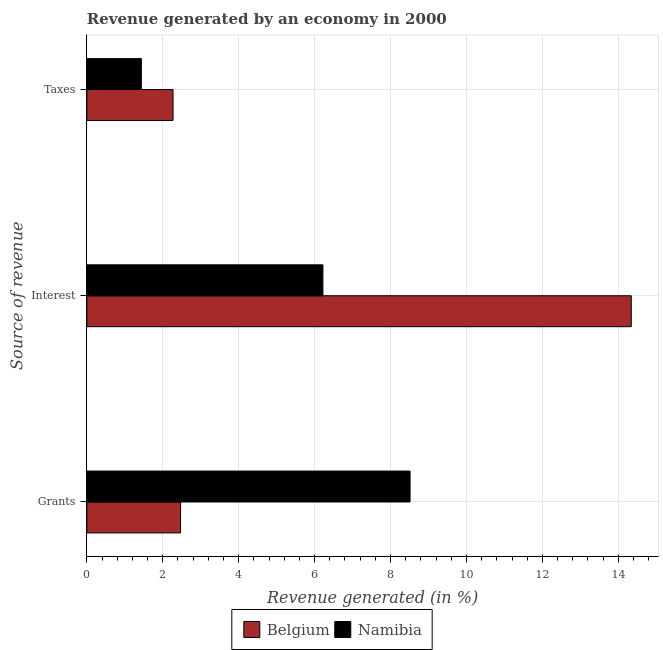Are the number of bars per tick equal to the number of legend labels?
Ensure brevity in your answer.  Yes. Are the number of bars on each tick of the Y-axis equal?
Ensure brevity in your answer.  Yes. How many bars are there on the 1st tick from the top?
Provide a short and direct response. 2. What is the label of the 2nd group of bars from the top?
Keep it short and to the point. Interest. What is the percentage of revenue generated by taxes in Namibia?
Offer a very short reply. 1.44. Across all countries, what is the maximum percentage of revenue generated by interest?
Your answer should be very brief. 14.34. Across all countries, what is the minimum percentage of revenue generated by interest?
Keep it short and to the point. 6.22. What is the total percentage of revenue generated by taxes in the graph?
Provide a short and direct response. 3.71. What is the difference between the percentage of revenue generated by interest in Belgium and that in Namibia?
Provide a succinct answer. 8.12. What is the difference between the percentage of revenue generated by grants in Namibia and the percentage of revenue generated by taxes in Belgium?
Make the answer very short. 6.24. What is the average percentage of revenue generated by taxes per country?
Your answer should be very brief. 1.85. What is the difference between the percentage of revenue generated by grants and percentage of revenue generated by interest in Belgium?
Your response must be concise. -11.87. What is the ratio of the percentage of revenue generated by taxes in Belgium to that in Namibia?
Your response must be concise. 1.58. Is the difference between the percentage of revenue generated by grants in Belgium and Namibia greater than the difference between the percentage of revenue generated by interest in Belgium and Namibia?
Offer a terse response. No. What is the difference between the highest and the second highest percentage of revenue generated by grants?
Your answer should be compact. 6.05. What is the difference between the highest and the lowest percentage of revenue generated by taxes?
Offer a terse response. 0.83. In how many countries, is the percentage of revenue generated by taxes greater than the average percentage of revenue generated by taxes taken over all countries?
Provide a succinct answer. 1. Is the sum of the percentage of revenue generated by grants in Namibia and Belgium greater than the maximum percentage of revenue generated by interest across all countries?
Offer a terse response. No. What does the 2nd bar from the bottom in Grants represents?
Keep it short and to the point. Namibia. Are all the bars in the graph horizontal?
Keep it short and to the point. Yes. How many countries are there in the graph?
Your answer should be very brief. 2. Are the values on the major ticks of X-axis written in scientific E-notation?
Ensure brevity in your answer.  No. How many legend labels are there?
Your answer should be very brief. 2. How are the legend labels stacked?
Offer a very short reply. Horizontal. What is the title of the graph?
Your answer should be compact. Revenue generated by an economy in 2000. What is the label or title of the X-axis?
Your response must be concise. Revenue generated (in %). What is the label or title of the Y-axis?
Provide a succinct answer. Source of revenue. What is the Revenue generated (in %) in Belgium in Grants?
Your answer should be very brief. 2.47. What is the Revenue generated (in %) of Namibia in Grants?
Offer a very short reply. 8.51. What is the Revenue generated (in %) of Belgium in Interest?
Your response must be concise. 14.34. What is the Revenue generated (in %) of Namibia in Interest?
Give a very brief answer. 6.22. What is the Revenue generated (in %) of Belgium in Taxes?
Offer a terse response. 2.27. What is the Revenue generated (in %) in Namibia in Taxes?
Provide a succinct answer. 1.44. Across all Source of revenue, what is the maximum Revenue generated (in %) in Belgium?
Offer a very short reply. 14.34. Across all Source of revenue, what is the maximum Revenue generated (in %) of Namibia?
Give a very brief answer. 8.51. Across all Source of revenue, what is the minimum Revenue generated (in %) in Belgium?
Your response must be concise. 2.27. Across all Source of revenue, what is the minimum Revenue generated (in %) of Namibia?
Offer a terse response. 1.44. What is the total Revenue generated (in %) in Belgium in the graph?
Your answer should be very brief. 19.08. What is the total Revenue generated (in %) of Namibia in the graph?
Your answer should be compact. 16.17. What is the difference between the Revenue generated (in %) in Belgium in Grants and that in Interest?
Your answer should be compact. -11.87. What is the difference between the Revenue generated (in %) of Namibia in Grants and that in Interest?
Give a very brief answer. 2.3. What is the difference between the Revenue generated (in %) in Belgium in Grants and that in Taxes?
Ensure brevity in your answer.  0.2. What is the difference between the Revenue generated (in %) in Namibia in Grants and that in Taxes?
Keep it short and to the point. 7.08. What is the difference between the Revenue generated (in %) in Belgium in Interest and that in Taxes?
Provide a short and direct response. 12.07. What is the difference between the Revenue generated (in %) in Namibia in Interest and that in Taxes?
Keep it short and to the point. 4.78. What is the difference between the Revenue generated (in %) in Belgium in Grants and the Revenue generated (in %) in Namibia in Interest?
Make the answer very short. -3.75. What is the difference between the Revenue generated (in %) in Belgium in Grants and the Revenue generated (in %) in Namibia in Taxes?
Provide a succinct answer. 1.03. What is the difference between the Revenue generated (in %) of Belgium in Interest and the Revenue generated (in %) of Namibia in Taxes?
Offer a very short reply. 12.91. What is the average Revenue generated (in %) in Belgium per Source of revenue?
Keep it short and to the point. 6.36. What is the average Revenue generated (in %) of Namibia per Source of revenue?
Your response must be concise. 5.39. What is the difference between the Revenue generated (in %) of Belgium and Revenue generated (in %) of Namibia in Grants?
Your answer should be very brief. -6.05. What is the difference between the Revenue generated (in %) of Belgium and Revenue generated (in %) of Namibia in Interest?
Offer a terse response. 8.12. What is the difference between the Revenue generated (in %) of Belgium and Revenue generated (in %) of Namibia in Taxes?
Your response must be concise. 0.83. What is the ratio of the Revenue generated (in %) of Belgium in Grants to that in Interest?
Ensure brevity in your answer.  0.17. What is the ratio of the Revenue generated (in %) of Namibia in Grants to that in Interest?
Offer a very short reply. 1.37. What is the ratio of the Revenue generated (in %) in Belgium in Grants to that in Taxes?
Give a very brief answer. 1.09. What is the ratio of the Revenue generated (in %) in Namibia in Grants to that in Taxes?
Provide a short and direct response. 5.93. What is the ratio of the Revenue generated (in %) of Belgium in Interest to that in Taxes?
Provide a succinct answer. 6.32. What is the ratio of the Revenue generated (in %) in Namibia in Interest to that in Taxes?
Your response must be concise. 4.33. What is the difference between the highest and the second highest Revenue generated (in %) in Belgium?
Your answer should be compact. 11.87. What is the difference between the highest and the second highest Revenue generated (in %) of Namibia?
Your response must be concise. 2.3. What is the difference between the highest and the lowest Revenue generated (in %) of Belgium?
Provide a short and direct response. 12.07. What is the difference between the highest and the lowest Revenue generated (in %) in Namibia?
Provide a succinct answer. 7.08. 